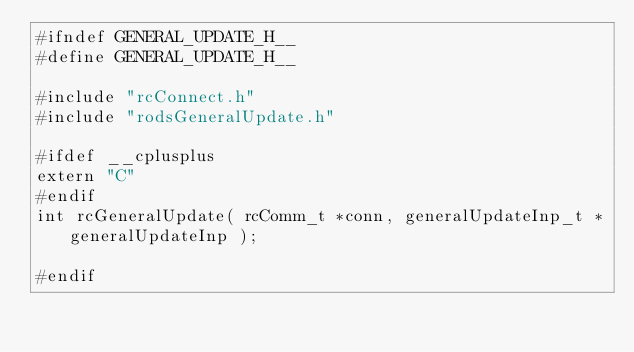Convert code to text. <code><loc_0><loc_0><loc_500><loc_500><_C_>#ifndef GENERAL_UPDATE_H__
#define GENERAL_UPDATE_H__

#include "rcConnect.h"
#include "rodsGeneralUpdate.h"

#ifdef __cplusplus
extern "C"
#endif
int rcGeneralUpdate( rcComm_t *conn, generalUpdateInp_t *generalUpdateInp );

#endif
</code> 